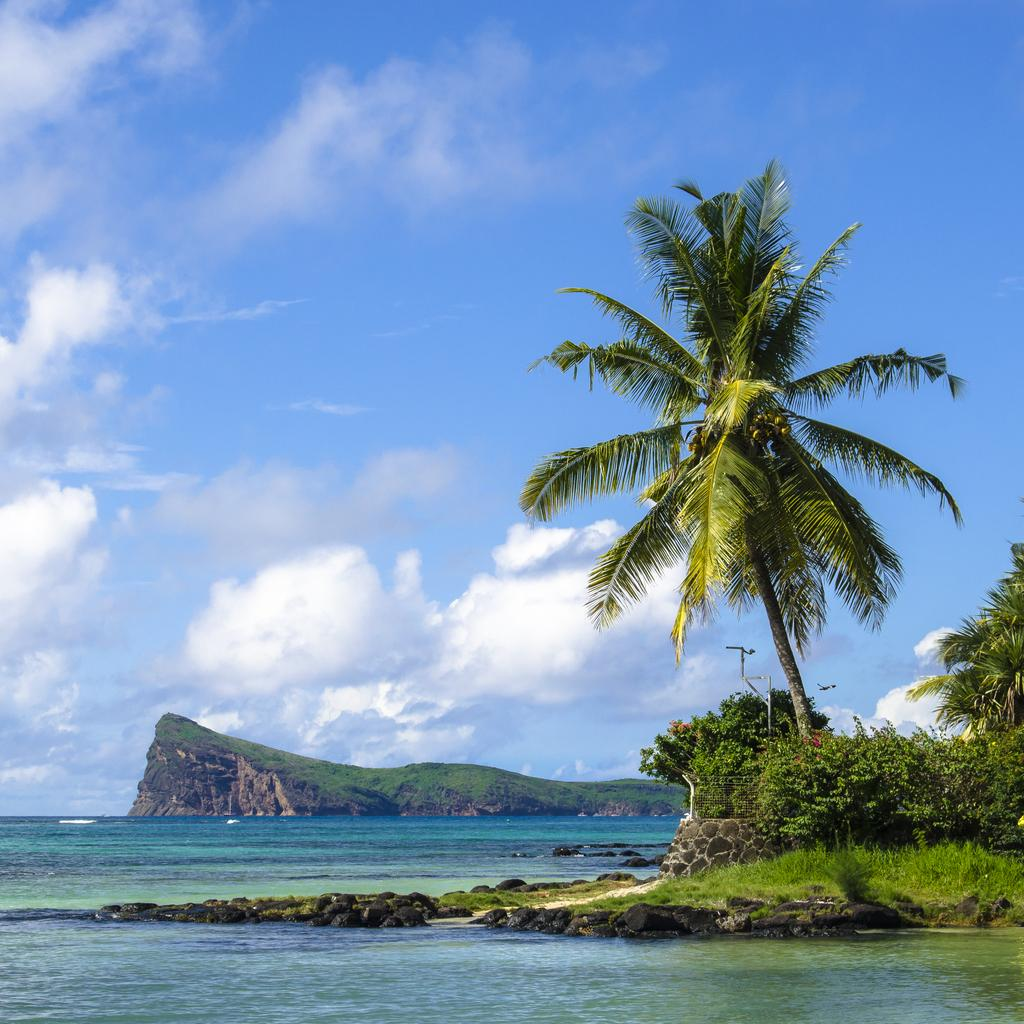What is the primary element visible in the image? There is water in the image. What type of vegetation can be seen on the ground in the image? There is grass on the ground in the image. What other types of vegetation are present in the image? There are plants and trees in the image. What is the color of the trees in the image? The trees are green in color. What can be seen in the background of the image? There is a mountain and the sky visible in the background of the image. What type of skirt is the mother wearing while sitting on the sofa in the image? There is no mother, skirt, or sofa present in the image. 